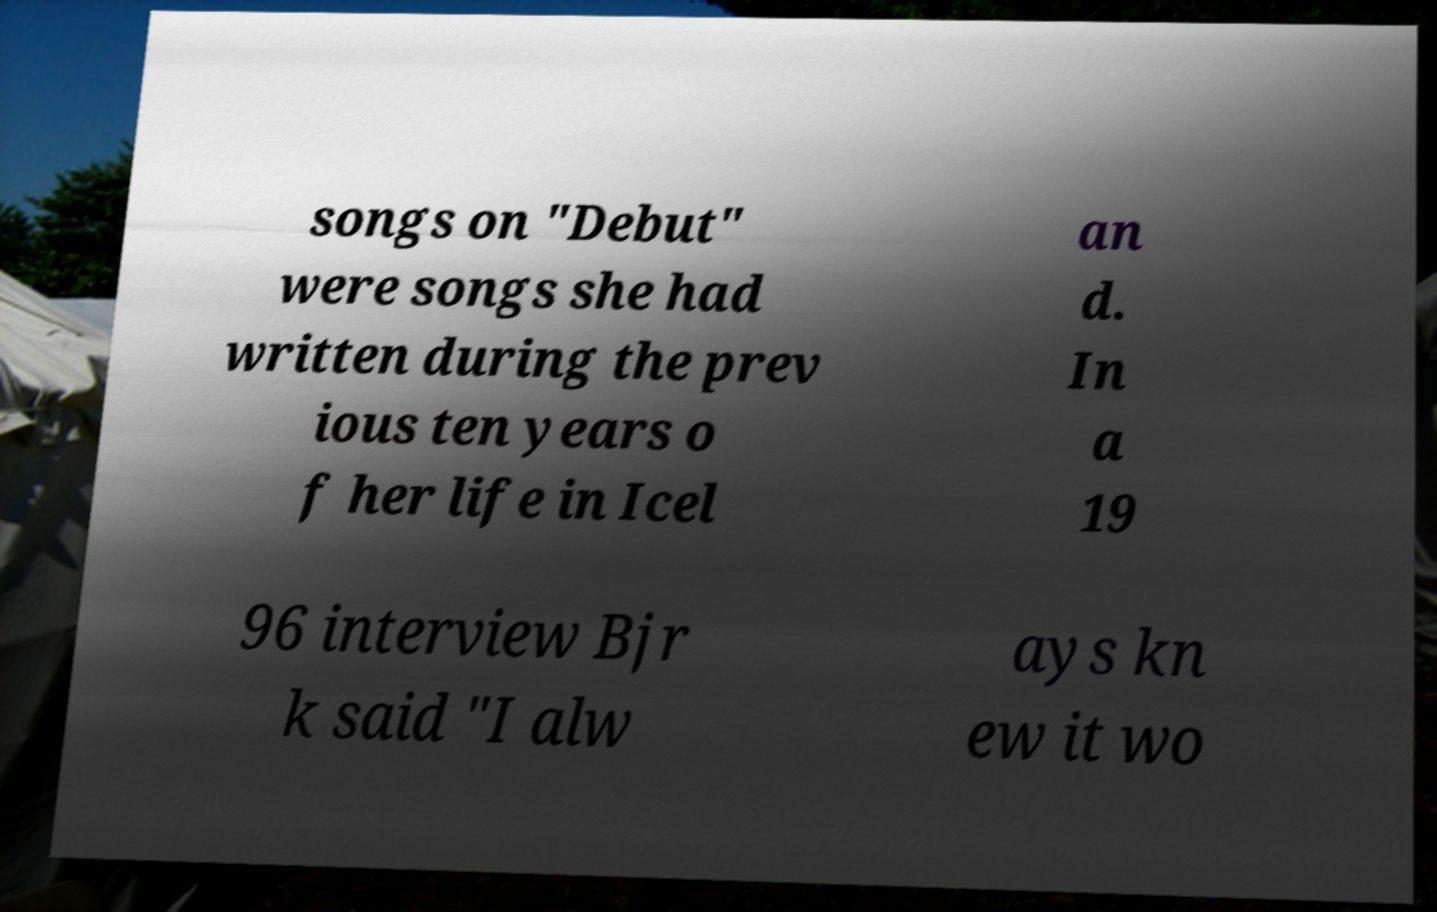There's text embedded in this image that I need extracted. Can you transcribe it verbatim? songs on "Debut" were songs she had written during the prev ious ten years o f her life in Icel an d. In a 19 96 interview Bjr k said "I alw ays kn ew it wo 